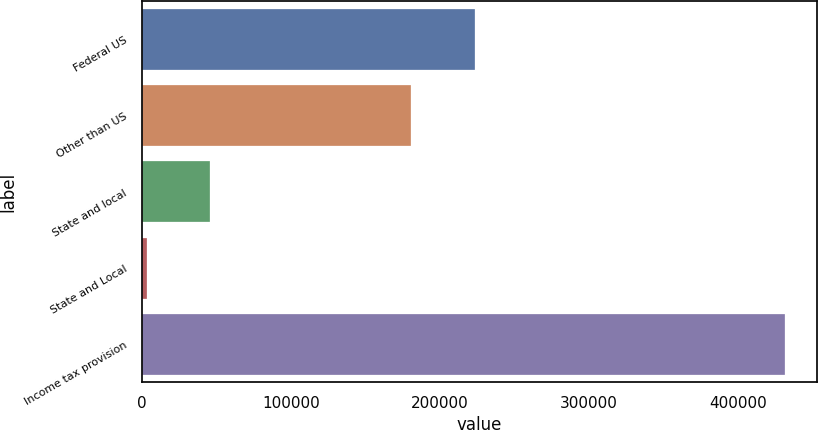<chart> <loc_0><loc_0><loc_500><loc_500><bar_chart><fcel>Federal US<fcel>Other than US<fcel>State and local<fcel>State and Local<fcel>Income tax provision<nl><fcel>223264<fcel>180401<fcel>45910.8<fcel>3048<fcel>431676<nl></chart> 